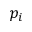<formula> <loc_0><loc_0><loc_500><loc_500>p _ { i }</formula> 